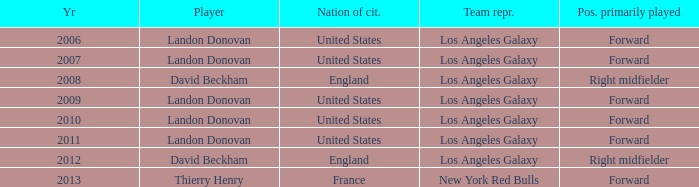What is the sum of all the years that Landon Donovan won the ESPY award? 5.0. 